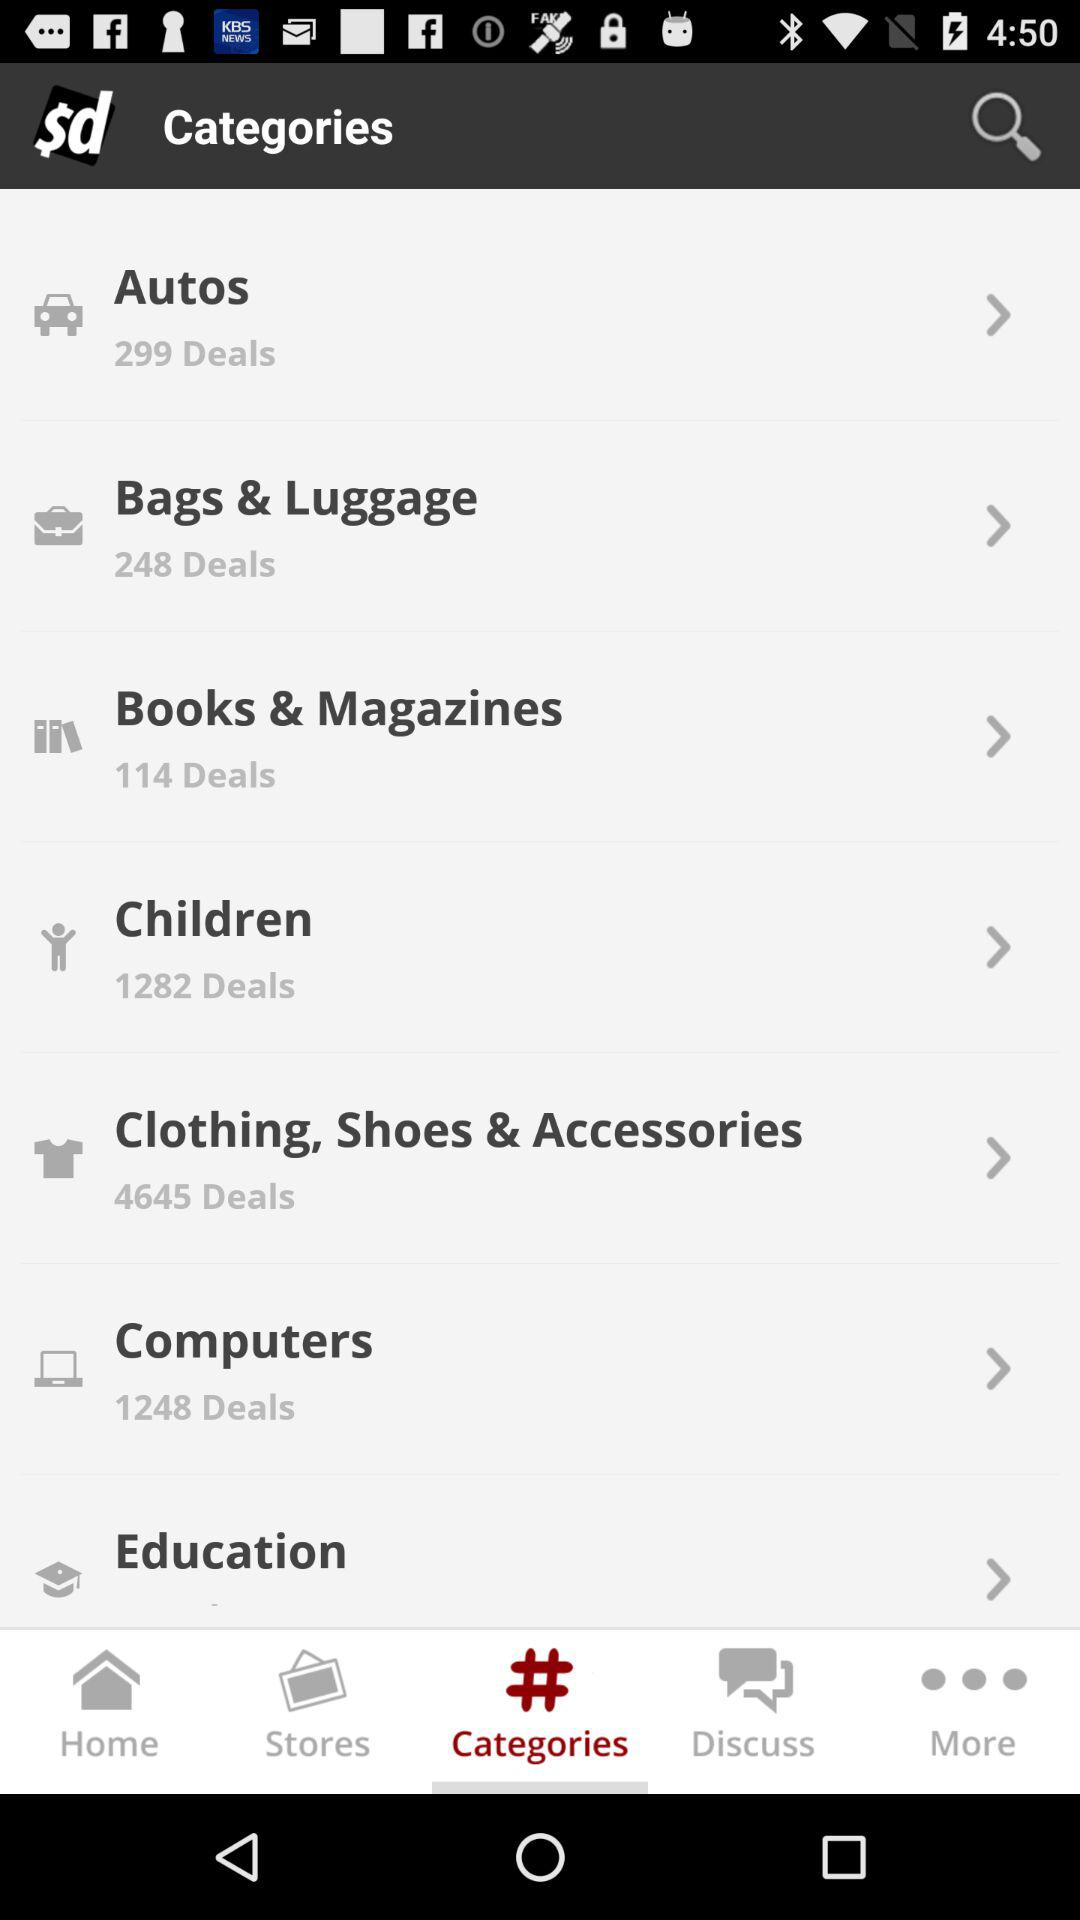How many deals are there in "Bags & Luggage"? There are 248 deals. 